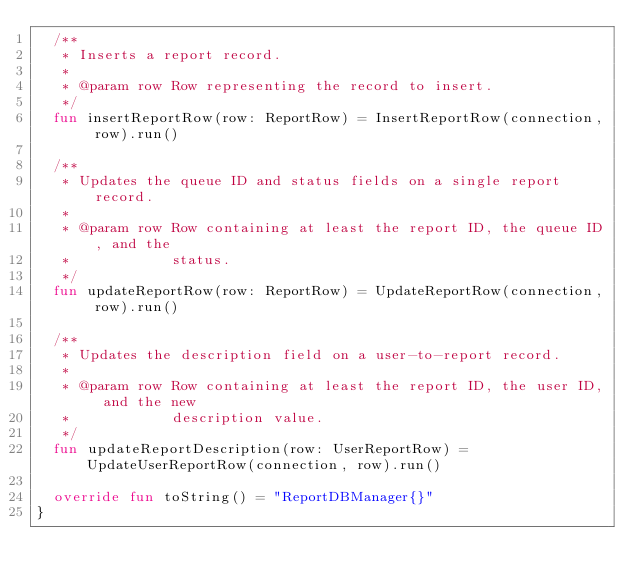<code> <loc_0><loc_0><loc_500><loc_500><_Kotlin_>  /**
   * Inserts a report record.
   *
   * @param row Row representing the record to insert.
   */
  fun insertReportRow(row: ReportRow) = InsertReportRow(connection, row).run()

  /**
   * Updates the queue ID and status fields on a single report record.
   *
   * @param row Row containing at least the report ID, the queue ID, and the
   *            status.
   */
  fun updateReportRow(row: ReportRow) = UpdateReportRow(connection, row).run()

  /**
   * Updates the description field on a user-to-report record.
   *
   * @param row Row containing at least the report ID, the user ID, and the new
   *            description value.
   */
  fun updateReportDescription(row: UserReportRow) = UpdateUserReportRow(connection, row).run()

  override fun toString() = "ReportDBManager{}"
}
</code> 